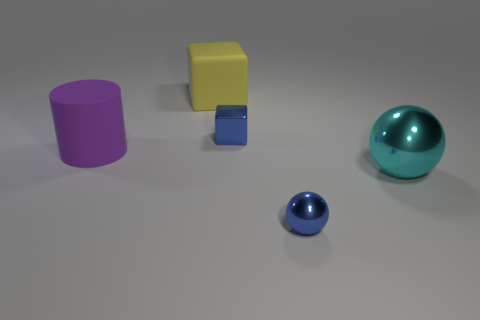Does the metallic object that is behind the purple object have the same size as the blue thing that is right of the tiny blue metal cube?
Offer a very short reply. Yes. What is the material of the blue object that is in front of the blue object behind the tiny ball?
Keep it short and to the point. Metal. Is the number of small metal things on the left side of the tiny blue shiny ball less than the number of blue shiny balls?
Your answer should be compact. No. There is a big purple thing that is the same material as the large yellow cube; what shape is it?
Provide a short and direct response. Cylinder. What number of other objects are the same shape as the cyan metallic thing?
Ensure brevity in your answer.  1. How many gray things are either big shiny things or matte blocks?
Your response must be concise. 0. Is the shape of the cyan metallic thing the same as the big purple object?
Keep it short and to the point. No. Are there any small blue metallic things on the left side of the blue metallic thing right of the tiny blue block?
Make the answer very short. Yes. Is the number of blue metallic balls on the right side of the cyan ball the same as the number of purple metallic cylinders?
Give a very brief answer. Yes. How many other things are there of the same size as the blue block?
Make the answer very short. 1. 